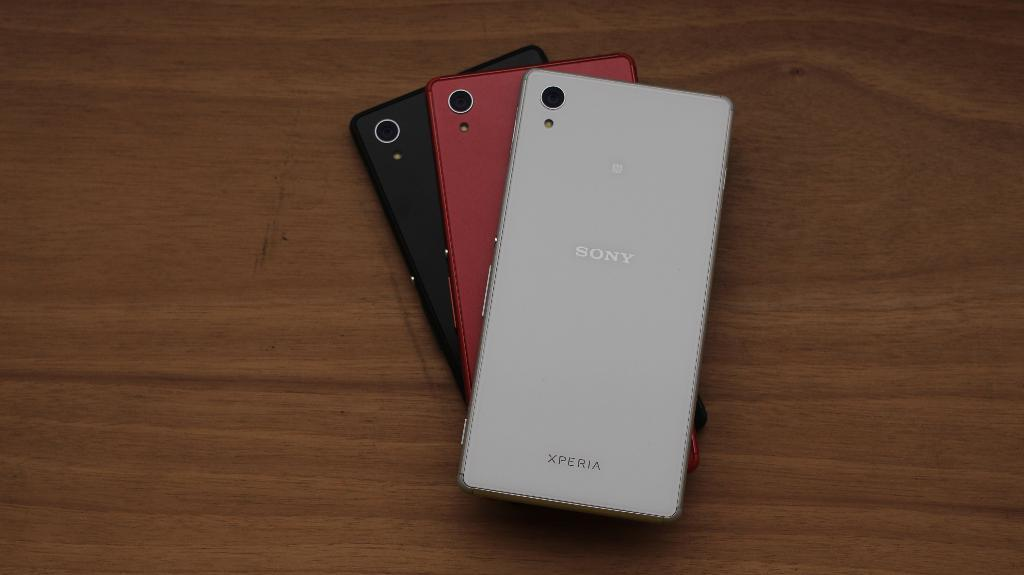<image>
Give a short and clear explanation of the subsequent image. Three Sony smartphones sit on a wooden table on top of a each other 